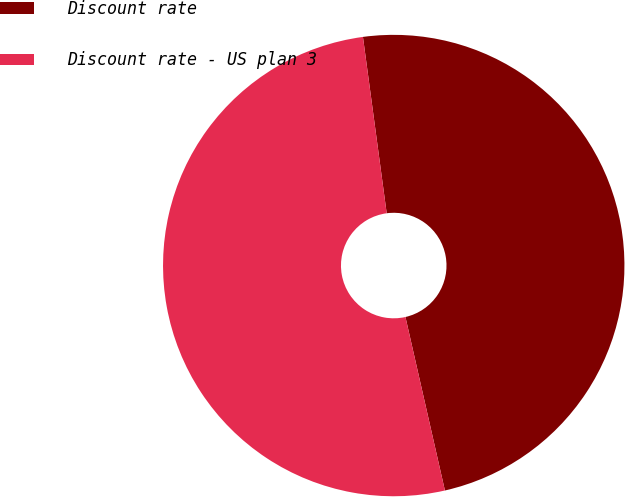<chart> <loc_0><loc_0><loc_500><loc_500><pie_chart><fcel>Discount rate<fcel>Discount rate - US plan 3<nl><fcel>48.57%<fcel>51.43%<nl></chart> 